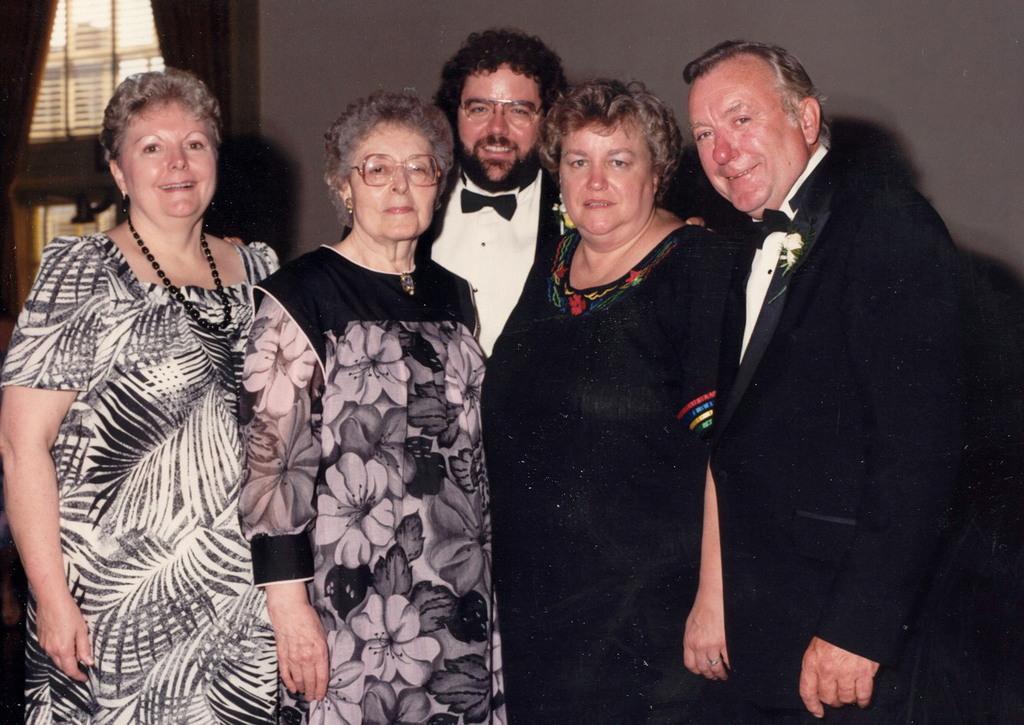Please provide a concise description of this image. In this image there are a group of people who are standing and smiling, and in the background there is a wall and window and some curtains. 